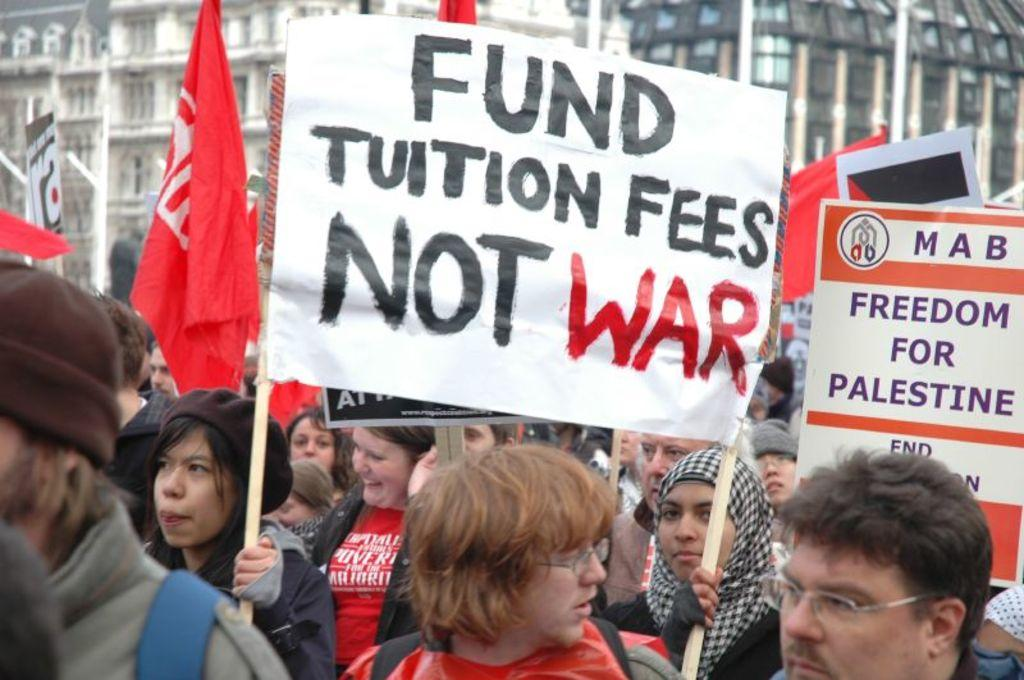Who or what is present in the image? There are people in the image. What are the people holding in the image? The people are holding placards and flags. What can be seen in the background of the image? There are buildings in the background of the image. Where is the cellar located in the image? There is no cellar present in the image. How many pins are attached to the flags in the image? There is no information about pins on the flags in the image. 